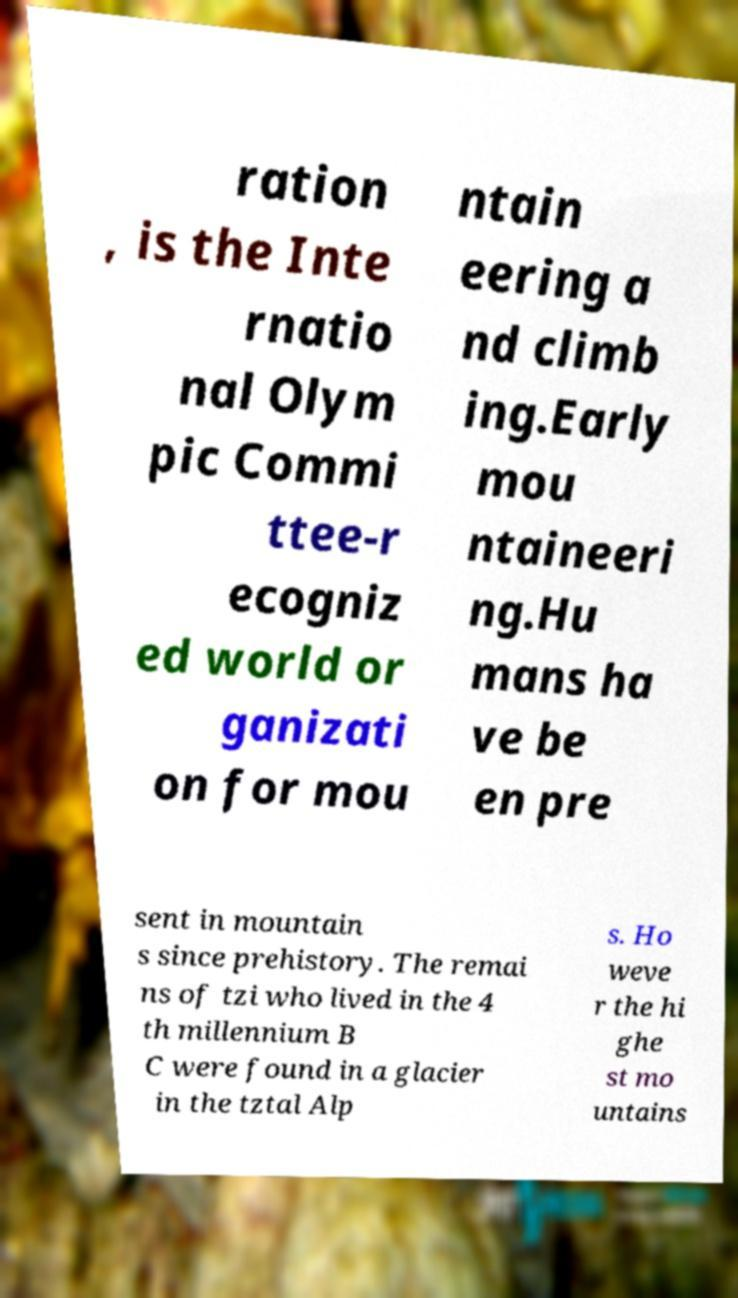I need the written content from this picture converted into text. Can you do that? ration , is the Inte rnatio nal Olym pic Commi ttee-r ecogniz ed world or ganizati on for mou ntain eering a nd climb ing.Early mou ntaineeri ng.Hu mans ha ve be en pre sent in mountain s since prehistory. The remai ns of tzi who lived in the 4 th millennium B C were found in a glacier in the tztal Alp s. Ho weve r the hi ghe st mo untains 